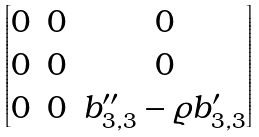<formula> <loc_0><loc_0><loc_500><loc_500>\begin{bmatrix} 0 & 0 & 0 \\ 0 & 0 & 0 \\ 0 & 0 & b _ { 3 , 3 } ^ { \prime \prime } - \varrho b _ { 3 , 3 } ^ { \prime } \end{bmatrix}</formula> 